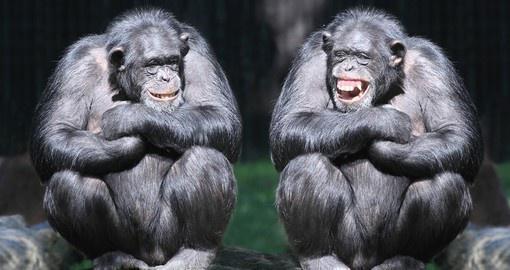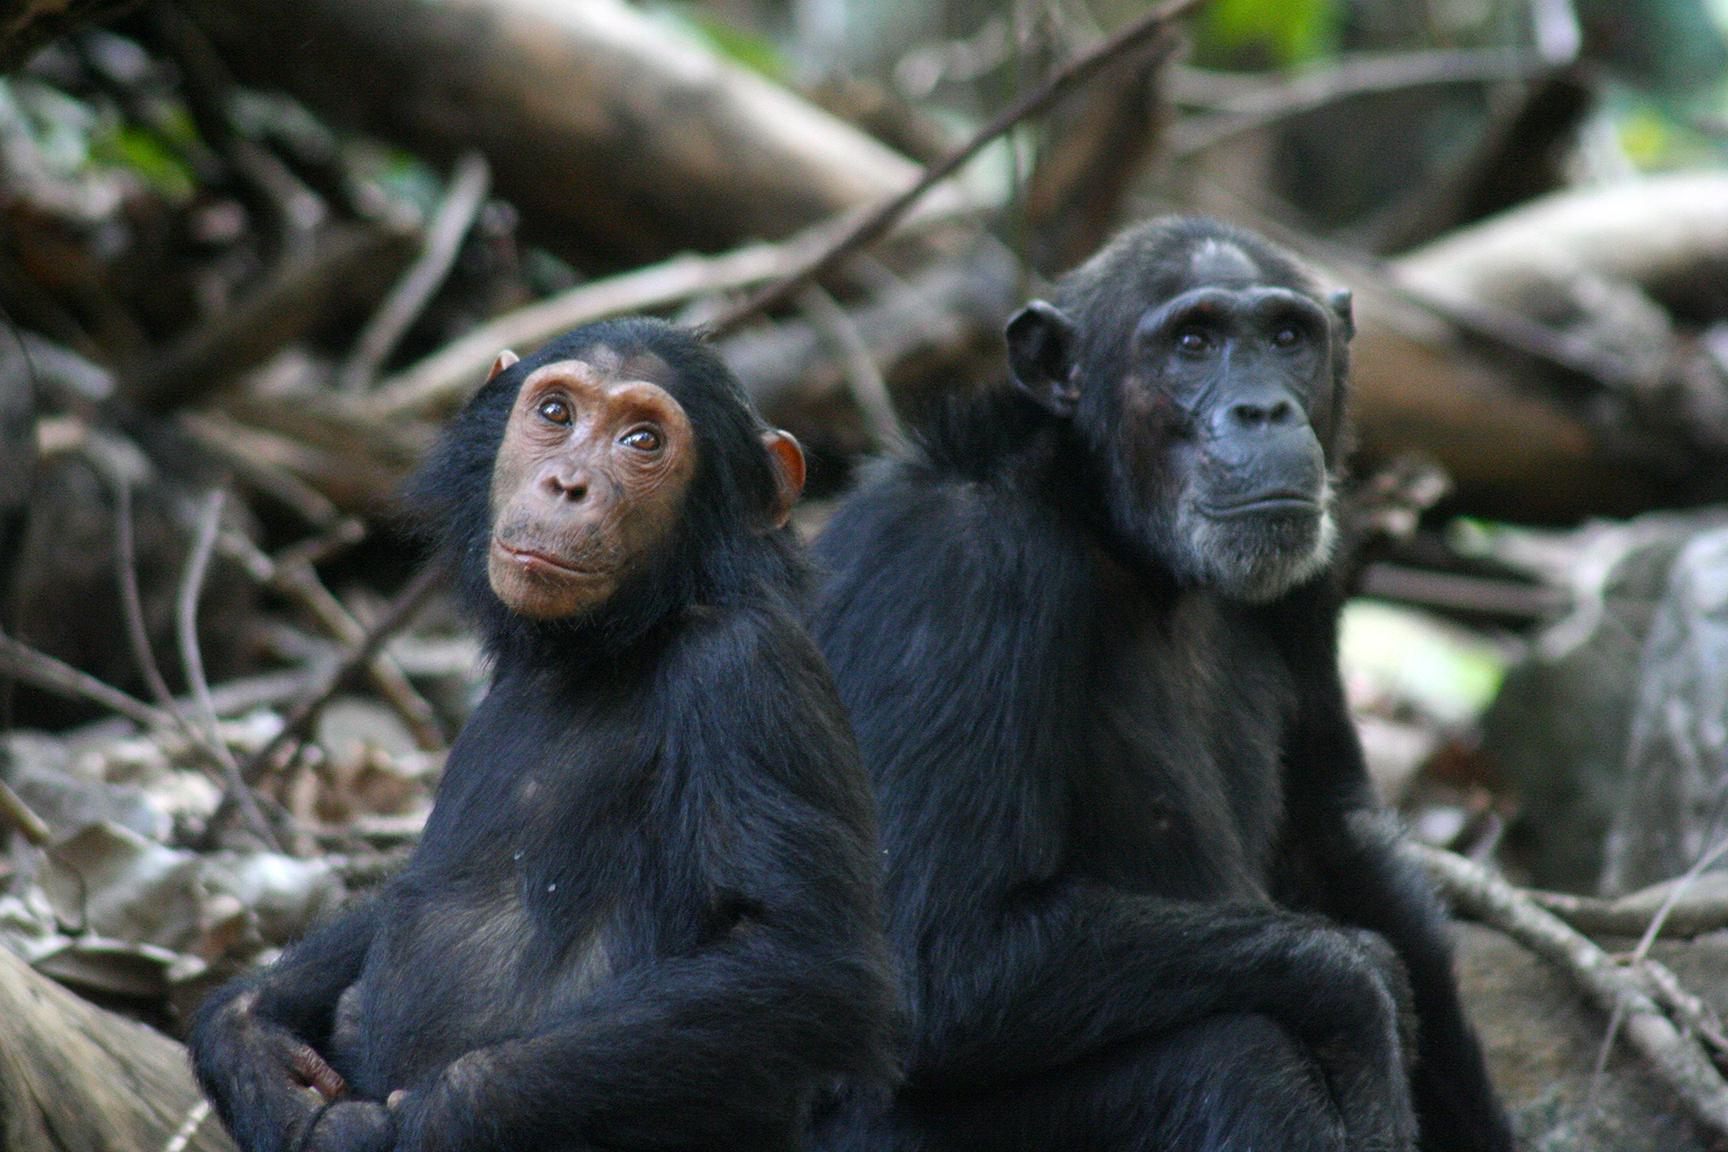The first image is the image on the left, the second image is the image on the right. Given the left and right images, does the statement "One chimp has a wide open mouth showing its front row of teeth." hold true? Answer yes or no. Yes. The first image is the image on the left, the second image is the image on the right. Analyze the images presented: Is the assertion "One of the animals in the image on the left has its teeth exposed." valid? Answer yes or no. Yes. 